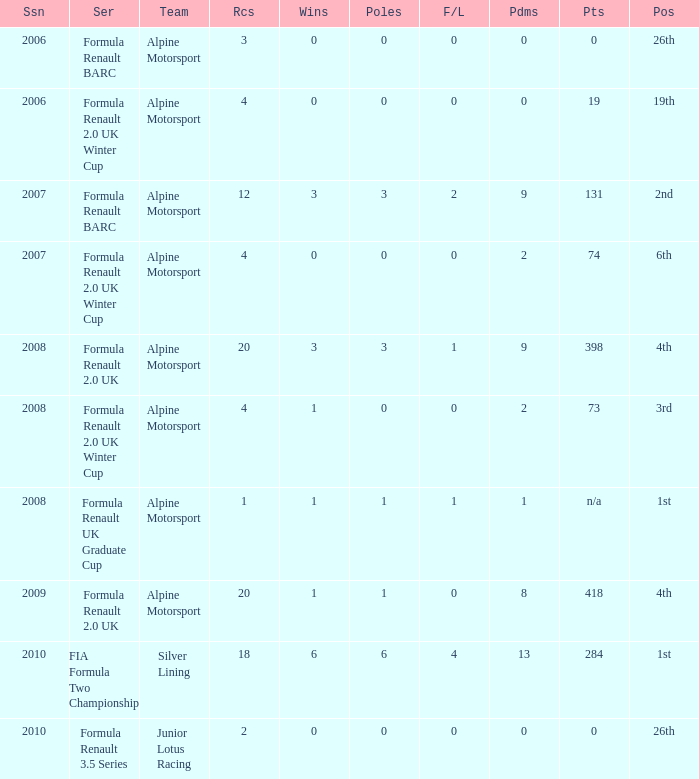How much were the f/laps if poles is higher than 1.0 during 2008? 1.0. 